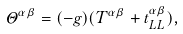Convert formula to latex. <formula><loc_0><loc_0><loc_500><loc_500>\Theta ^ { \alpha \beta } = ( - g ) ( T ^ { \alpha \beta } + t ^ { \alpha \beta } _ { L L } ) ,</formula> 